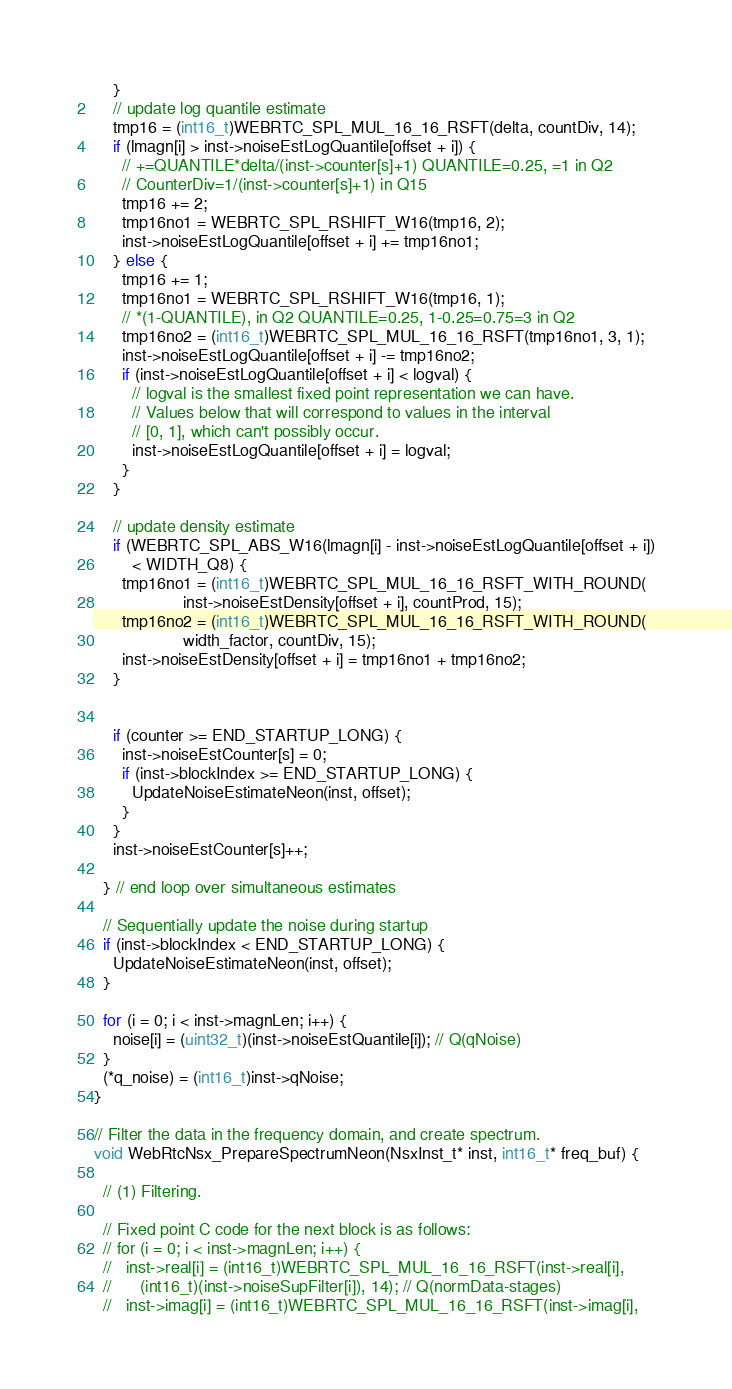Convert code to text. <code><loc_0><loc_0><loc_500><loc_500><_C_>    }
    // update log quantile estimate
    tmp16 = (int16_t)WEBRTC_SPL_MUL_16_16_RSFT(delta, countDiv, 14);
    if (lmagn[i] > inst->noiseEstLogQuantile[offset + i]) {
      // +=QUANTILE*delta/(inst->counter[s]+1) QUANTILE=0.25, =1 in Q2
      // CounterDiv=1/(inst->counter[s]+1) in Q15
      tmp16 += 2;
      tmp16no1 = WEBRTC_SPL_RSHIFT_W16(tmp16, 2);
      inst->noiseEstLogQuantile[offset + i] += tmp16no1;
    } else {
      tmp16 += 1;
      tmp16no1 = WEBRTC_SPL_RSHIFT_W16(tmp16, 1);
      // *(1-QUANTILE), in Q2 QUANTILE=0.25, 1-0.25=0.75=3 in Q2
      tmp16no2 = (int16_t)WEBRTC_SPL_MUL_16_16_RSFT(tmp16no1, 3, 1);
      inst->noiseEstLogQuantile[offset + i] -= tmp16no2;
      if (inst->noiseEstLogQuantile[offset + i] < logval) {
        // logval is the smallest fixed point representation we can have.
        // Values below that will correspond to values in the interval
        // [0, 1], which can't possibly occur.
        inst->noiseEstLogQuantile[offset + i] = logval;
      }
    }

    // update density estimate
    if (WEBRTC_SPL_ABS_W16(lmagn[i] - inst->noiseEstLogQuantile[offset + i])
        < WIDTH_Q8) {
      tmp16no1 = (int16_t)WEBRTC_SPL_MUL_16_16_RSFT_WITH_ROUND(
                   inst->noiseEstDensity[offset + i], countProd, 15);
      tmp16no2 = (int16_t)WEBRTC_SPL_MUL_16_16_RSFT_WITH_ROUND(
                   width_factor, countDiv, 15);
      inst->noiseEstDensity[offset + i] = tmp16no1 + tmp16no2;
    }


    if (counter >= END_STARTUP_LONG) {
      inst->noiseEstCounter[s] = 0;
      if (inst->blockIndex >= END_STARTUP_LONG) {
        UpdateNoiseEstimateNeon(inst, offset);
      }
    }
    inst->noiseEstCounter[s]++;

  } // end loop over simultaneous estimates

  // Sequentially update the noise during startup
  if (inst->blockIndex < END_STARTUP_LONG) {
    UpdateNoiseEstimateNeon(inst, offset);
  }

  for (i = 0; i < inst->magnLen; i++) {
    noise[i] = (uint32_t)(inst->noiseEstQuantile[i]); // Q(qNoise)
  }
  (*q_noise) = (int16_t)inst->qNoise;
}

// Filter the data in the frequency domain, and create spectrum.
void WebRtcNsx_PrepareSpectrumNeon(NsxInst_t* inst, int16_t* freq_buf) {

  // (1) Filtering.

  // Fixed point C code for the next block is as follows:
  // for (i = 0; i < inst->magnLen; i++) {
  //   inst->real[i] = (int16_t)WEBRTC_SPL_MUL_16_16_RSFT(inst->real[i],
  //      (int16_t)(inst->noiseSupFilter[i]), 14); // Q(normData-stages)
  //   inst->imag[i] = (int16_t)WEBRTC_SPL_MUL_16_16_RSFT(inst->imag[i],</code> 